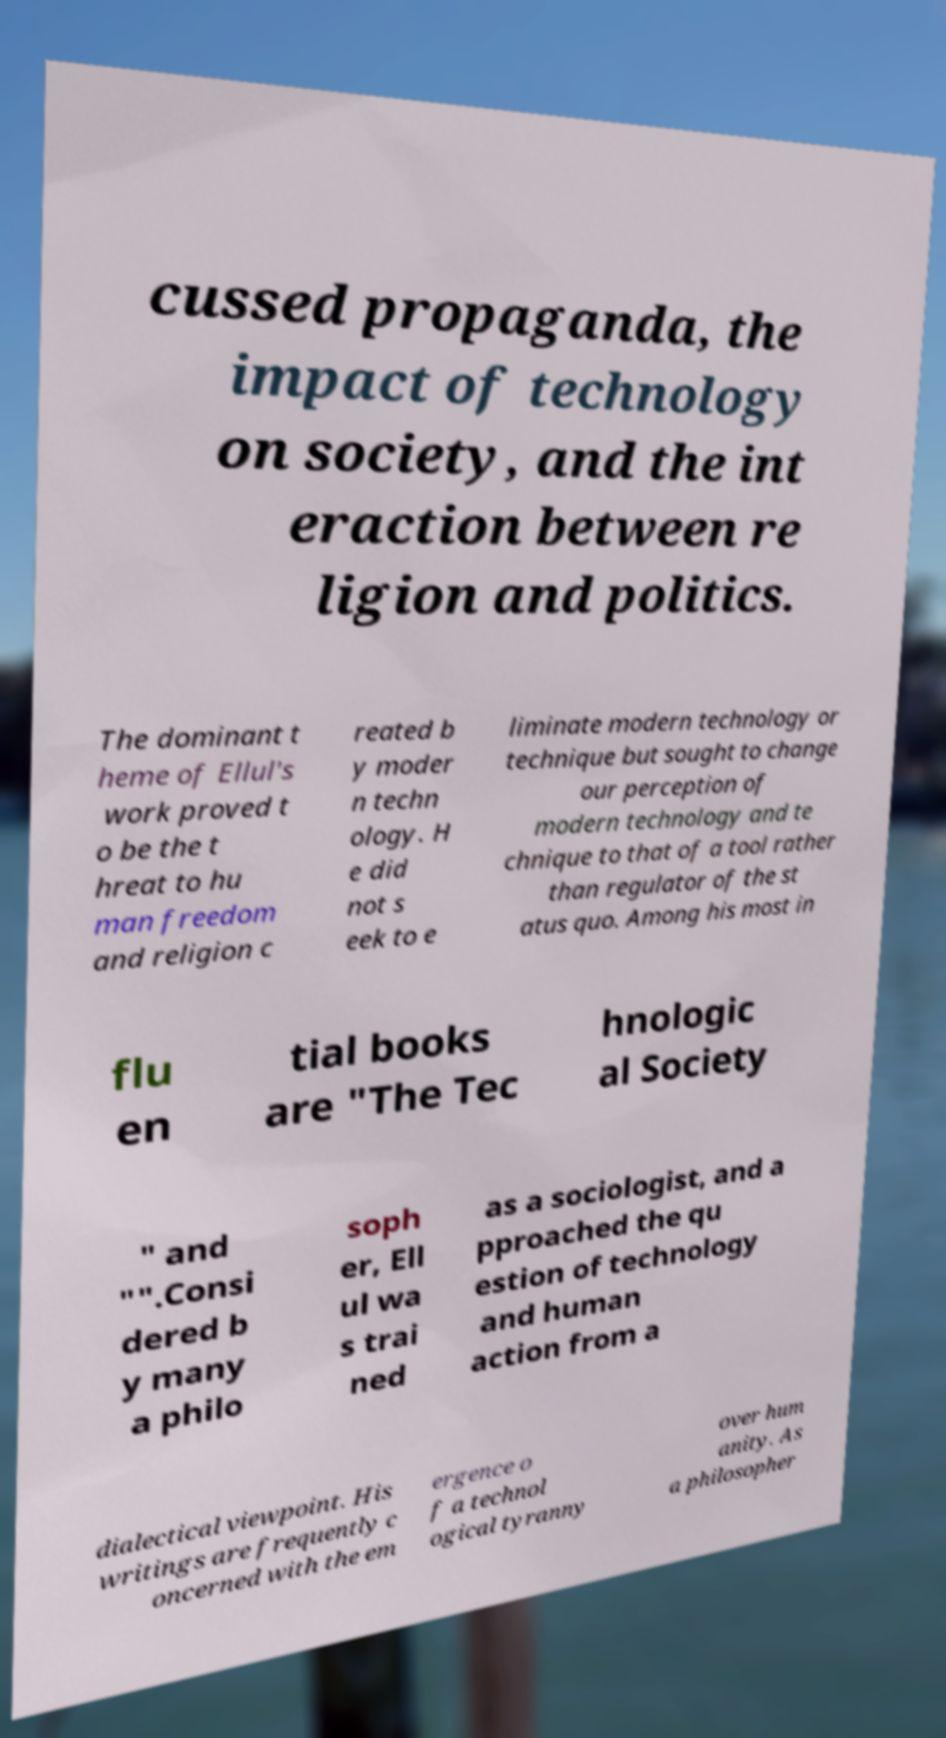There's text embedded in this image that I need extracted. Can you transcribe it verbatim? cussed propaganda, the impact of technology on society, and the int eraction between re ligion and politics. The dominant t heme of Ellul's work proved t o be the t hreat to hu man freedom and religion c reated b y moder n techn ology. H e did not s eek to e liminate modern technology or technique but sought to change our perception of modern technology and te chnique to that of a tool rather than regulator of the st atus quo. Among his most in flu en tial books are "The Tec hnologic al Society " and "".Consi dered b y many a philo soph er, Ell ul wa s trai ned as a sociologist, and a pproached the qu estion of technology and human action from a dialectical viewpoint. His writings are frequently c oncerned with the em ergence o f a technol ogical tyranny over hum anity. As a philosopher 